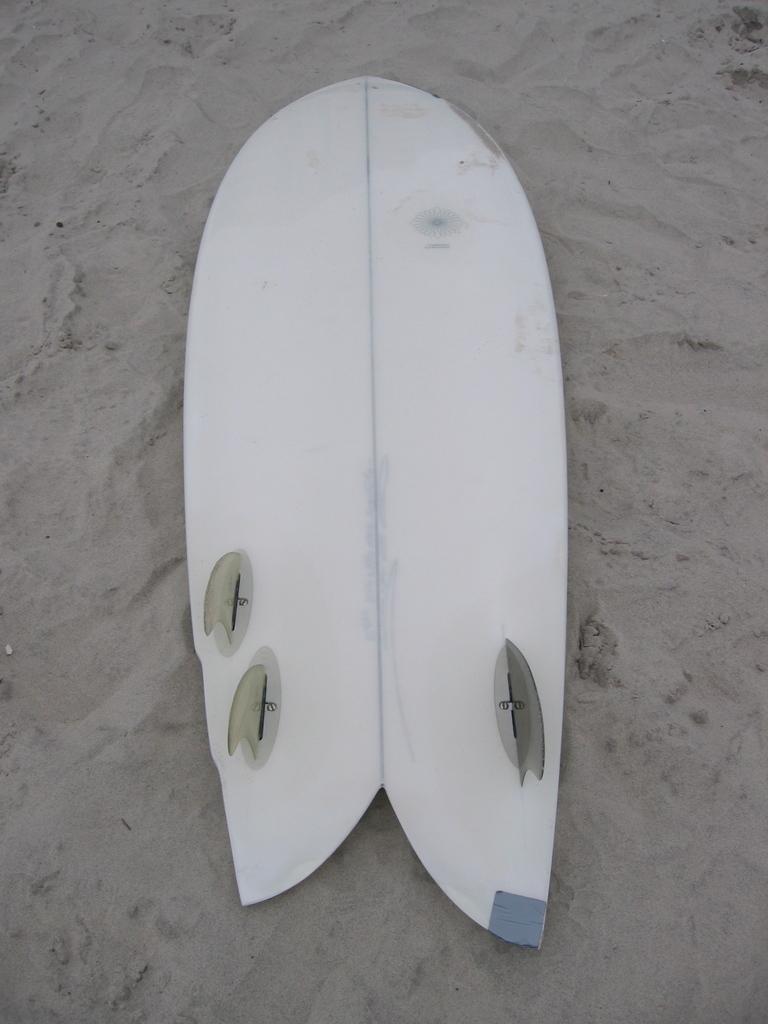Can you describe this image briefly? In this image I can see a surfboard which is white in color on the sand which is grey in color. 